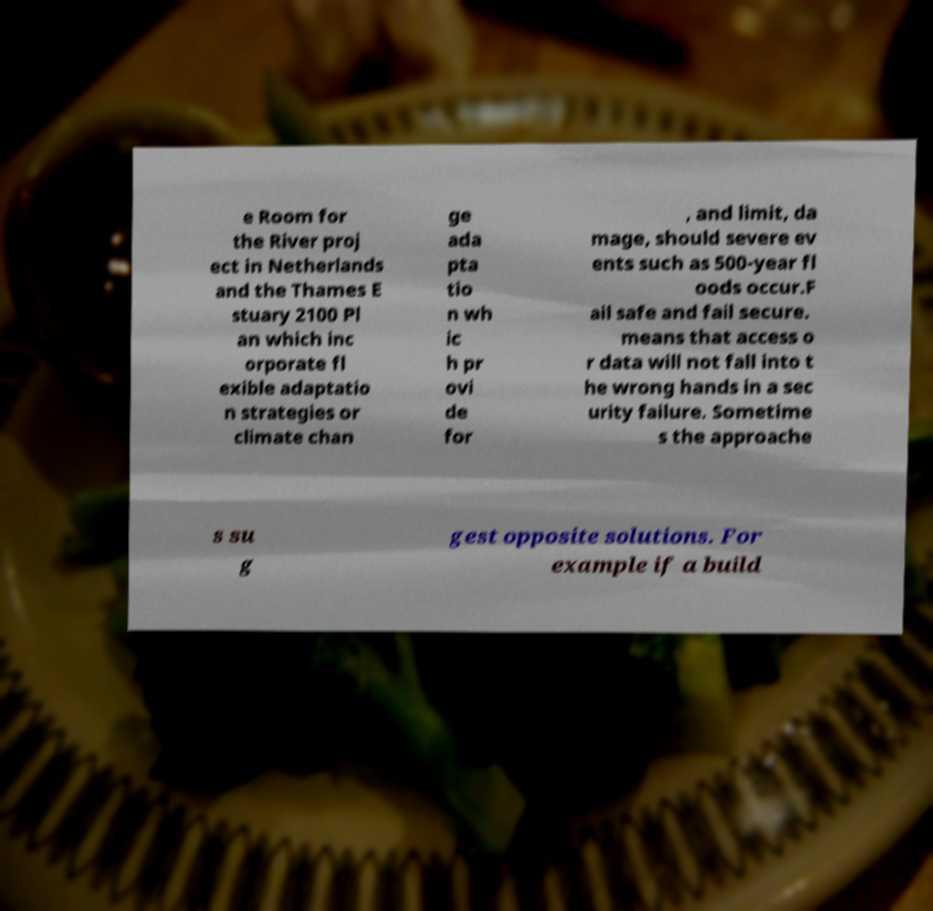What messages or text are displayed in this image? I need them in a readable, typed format. e Room for the River proj ect in Netherlands and the Thames E stuary 2100 Pl an which inc orporate fl exible adaptatio n strategies or climate chan ge ada pta tio n wh ic h pr ovi de for , and limit, da mage, should severe ev ents such as 500-year fl oods occur.F ail safe and fail secure. means that access o r data will not fall into t he wrong hands in a sec urity failure. Sometime s the approache s su g gest opposite solutions. For example if a build 